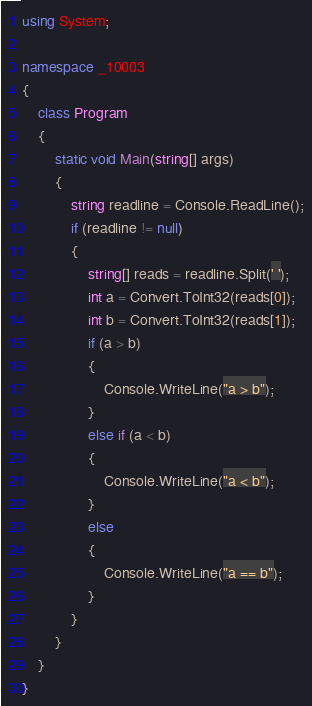Convert code to text. <code><loc_0><loc_0><loc_500><loc_500><_C#_>using System;

namespace _10003
{
    class Program
    {
        static void Main(string[] args)
        {
            string readline = Console.ReadLine();
            if (readline != null)
            {
                string[] reads = readline.Split(' ');
                int a = Convert.ToInt32(reads[0]);
                int b = Convert.ToInt32(reads[1]);
                if (a > b)
                {
                    Console.WriteLine("a > b");
                }
                else if (a < b)
                {
                    Console.WriteLine("a < b");
                }
                else
                {
                    Console.WriteLine("a == b");
                }
            }
        }
    }
}</code> 